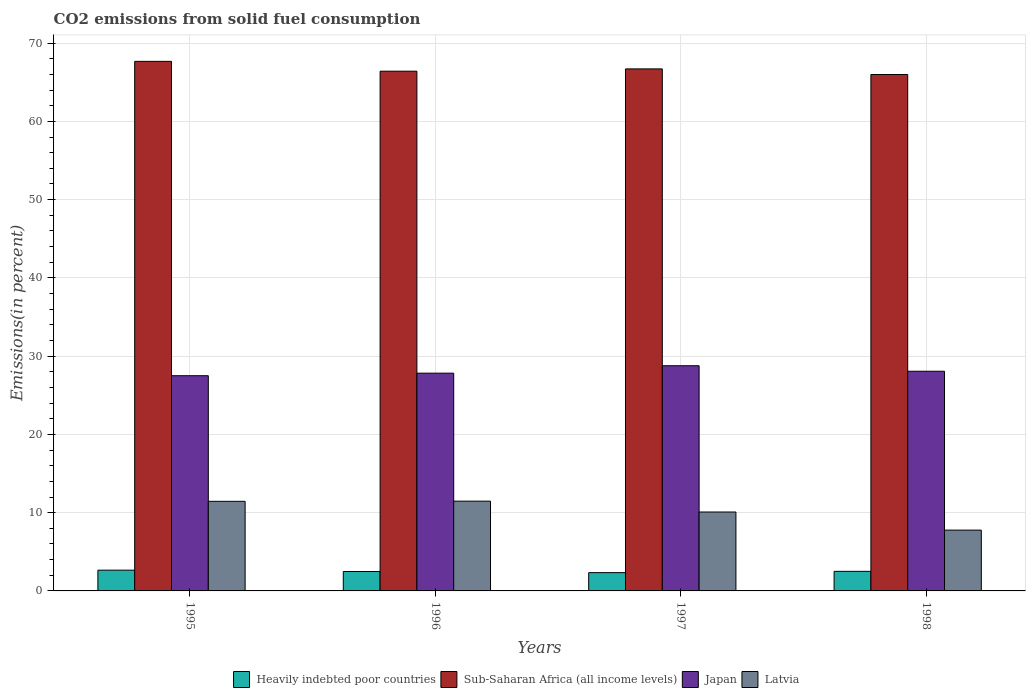How many groups of bars are there?
Provide a succinct answer. 4. Are the number of bars per tick equal to the number of legend labels?
Offer a terse response. Yes. Are the number of bars on each tick of the X-axis equal?
Give a very brief answer. Yes. In how many cases, is the number of bars for a given year not equal to the number of legend labels?
Your response must be concise. 0. What is the total CO2 emitted in Latvia in 1996?
Provide a short and direct response. 11.47. Across all years, what is the maximum total CO2 emitted in Latvia?
Provide a short and direct response. 11.47. Across all years, what is the minimum total CO2 emitted in Latvia?
Keep it short and to the point. 7.77. In which year was the total CO2 emitted in Heavily indebted poor countries minimum?
Give a very brief answer. 1997. What is the total total CO2 emitted in Sub-Saharan Africa (all income levels) in the graph?
Offer a very short reply. 266.77. What is the difference between the total CO2 emitted in Japan in 1997 and that in 1998?
Offer a terse response. 0.7. What is the difference between the total CO2 emitted in Japan in 1996 and the total CO2 emitted in Sub-Saharan Africa (all income levels) in 1995?
Offer a very short reply. -39.84. What is the average total CO2 emitted in Heavily indebted poor countries per year?
Give a very brief answer. 2.49. In the year 1997, what is the difference between the total CO2 emitted in Japan and total CO2 emitted in Heavily indebted poor countries?
Keep it short and to the point. 26.44. In how many years, is the total CO2 emitted in Sub-Saharan Africa (all income levels) greater than 60 %?
Offer a very short reply. 4. What is the ratio of the total CO2 emitted in Japan in 1995 to that in 1997?
Provide a succinct answer. 0.96. What is the difference between the highest and the second highest total CO2 emitted in Japan?
Provide a short and direct response. 0.7. What is the difference between the highest and the lowest total CO2 emitted in Heavily indebted poor countries?
Make the answer very short. 0.32. In how many years, is the total CO2 emitted in Japan greater than the average total CO2 emitted in Japan taken over all years?
Ensure brevity in your answer.  2. What does the 1st bar from the left in 1997 represents?
Ensure brevity in your answer.  Heavily indebted poor countries. What does the 1st bar from the right in 1997 represents?
Provide a short and direct response. Latvia. How many bars are there?
Your response must be concise. 16. How many years are there in the graph?
Make the answer very short. 4. What is the difference between two consecutive major ticks on the Y-axis?
Your response must be concise. 10. Are the values on the major ticks of Y-axis written in scientific E-notation?
Give a very brief answer. No. Does the graph contain any zero values?
Your answer should be very brief. No. Where does the legend appear in the graph?
Ensure brevity in your answer.  Bottom center. What is the title of the graph?
Offer a terse response. CO2 emissions from solid fuel consumption. What is the label or title of the X-axis?
Ensure brevity in your answer.  Years. What is the label or title of the Y-axis?
Provide a succinct answer. Emissions(in percent). What is the Emissions(in percent) in Heavily indebted poor countries in 1995?
Offer a terse response. 2.65. What is the Emissions(in percent) in Sub-Saharan Africa (all income levels) in 1995?
Keep it short and to the point. 67.67. What is the Emissions(in percent) in Japan in 1995?
Your answer should be very brief. 27.5. What is the Emissions(in percent) of Latvia in 1995?
Make the answer very short. 11.45. What is the Emissions(in percent) in Heavily indebted poor countries in 1996?
Make the answer very short. 2.48. What is the Emissions(in percent) in Sub-Saharan Africa (all income levels) in 1996?
Give a very brief answer. 66.41. What is the Emissions(in percent) of Japan in 1996?
Make the answer very short. 27.83. What is the Emissions(in percent) in Latvia in 1996?
Offer a terse response. 11.47. What is the Emissions(in percent) in Heavily indebted poor countries in 1997?
Provide a short and direct response. 2.34. What is the Emissions(in percent) in Sub-Saharan Africa (all income levels) in 1997?
Your answer should be compact. 66.7. What is the Emissions(in percent) in Japan in 1997?
Keep it short and to the point. 28.77. What is the Emissions(in percent) of Latvia in 1997?
Your answer should be very brief. 10.08. What is the Emissions(in percent) in Heavily indebted poor countries in 1998?
Your answer should be compact. 2.5. What is the Emissions(in percent) of Sub-Saharan Africa (all income levels) in 1998?
Give a very brief answer. 65.99. What is the Emissions(in percent) in Japan in 1998?
Offer a very short reply. 28.07. What is the Emissions(in percent) in Latvia in 1998?
Your answer should be very brief. 7.77. Across all years, what is the maximum Emissions(in percent) of Heavily indebted poor countries?
Ensure brevity in your answer.  2.65. Across all years, what is the maximum Emissions(in percent) of Sub-Saharan Africa (all income levels)?
Ensure brevity in your answer.  67.67. Across all years, what is the maximum Emissions(in percent) of Japan?
Your answer should be very brief. 28.77. Across all years, what is the maximum Emissions(in percent) in Latvia?
Offer a terse response. 11.47. Across all years, what is the minimum Emissions(in percent) in Heavily indebted poor countries?
Your answer should be compact. 2.34. Across all years, what is the minimum Emissions(in percent) in Sub-Saharan Africa (all income levels)?
Ensure brevity in your answer.  65.99. Across all years, what is the minimum Emissions(in percent) of Japan?
Provide a short and direct response. 27.5. Across all years, what is the minimum Emissions(in percent) of Latvia?
Provide a succinct answer. 7.77. What is the total Emissions(in percent) of Heavily indebted poor countries in the graph?
Offer a terse response. 9.97. What is the total Emissions(in percent) of Sub-Saharan Africa (all income levels) in the graph?
Ensure brevity in your answer.  266.77. What is the total Emissions(in percent) in Japan in the graph?
Your answer should be compact. 112.17. What is the total Emissions(in percent) in Latvia in the graph?
Your answer should be very brief. 40.77. What is the difference between the Emissions(in percent) in Heavily indebted poor countries in 1995 and that in 1996?
Ensure brevity in your answer.  0.17. What is the difference between the Emissions(in percent) of Sub-Saharan Africa (all income levels) in 1995 and that in 1996?
Make the answer very short. 1.26. What is the difference between the Emissions(in percent) of Japan in 1995 and that in 1996?
Your answer should be compact. -0.33. What is the difference between the Emissions(in percent) of Latvia in 1995 and that in 1996?
Your response must be concise. -0.02. What is the difference between the Emissions(in percent) in Heavily indebted poor countries in 1995 and that in 1997?
Keep it short and to the point. 0.32. What is the difference between the Emissions(in percent) of Sub-Saharan Africa (all income levels) in 1995 and that in 1997?
Offer a very short reply. 0.96. What is the difference between the Emissions(in percent) in Japan in 1995 and that in 1997?
Ensure brevity in your answer.  -1.27. What is the difference between the Emissions(in percent) in Latvia in 1995 and that in 1997?
Keep it short and to the point. 1.37. What is the difference between the Emissions(in percent) in Heavily indebted poor countries in 1995 and that in 1998?
Give a very brief answer. 0.15. What is the difference between the Emissions(in percent) in Sub-Saharan Africa (all income levels) in 1995 and that in 1998?
Make the answer very short. 1.68. What is the difference between the Emissions(in percent) in Japan in 1995 and that in 1998?
Offer a very short reply. -0.57. What is the difference between the Emissions(in percent) in Latvia in 1995 and that in 1998?
Your answer should be very brief. 3.68. What is the difference between the Emissions(in percent) of Heavily indebted poor countries in 1996 and that in 1997?
Provide a succinct answer. 0.15. What is the difference between the Emissions(in percent) of Sub-Saharan Africa (all income levels) in 1996 and that in 1997?
Keep it short and to the point. -0.29. What is the difference between the Emissions(in percent) in Japan in 1996 and that in 1997?
Give a very brief answer. -0.95. What is the difference between the Emissions(in percent) of Latvia in 1996 and that in 1997?
Make the answer very short. 1.39. What is the difference between the Emissions(in percent) in Heavily indebted poor countries in 1996 and that in 1998?
Keep it short and to the point. -0.02. What is the difference between the Emissions(in percent) of Sub-Saharan Africa (all income levels) in 1996 and that in 1998?
Keep it short and to the point. 0.42. What is the difference between the Emissions(in percent) of Japan in 1996 and that in 1998?
Your response must be concise. -0.25. What is the difference between the Emissions(in percent) in Latvia in 1996 and that in 1998?
Your answer should be very brief. 3.7. What is the difference between the Emissions(in percent) of Heavily indebted poor countries in 1997 and that in 1998?
Offer a very short reply. -0.17. What is the difference between the Emissions(in percent) in Sub-Saharan Africa (all income levels) in 1997 and that in 1998?
Offer a very short reply. 0.72. What is the difference between the Emissions(in percent) of Japan in 1997 and that in 1998?
Your response must be concise. 0.7. What is the difference between the Emissions(in percent) in Latvia in 1997 and that in 1998?
Provide a short and direct response. 2.31. What is the difference between the Emissions(in percent) of Heavily indebted poor countries in 1995 and the Emissions(in percent) of Sub-Saharan Africa (all income levels) in 1996?
Make the answer very short. -63.76. What is the difference between the Emissions(in percent) of Heavily indebted poor countries in 1995 and the Emissions(in percent) of Japan in 1996?
Offer a terse response. -25.17. What is the difference between the Emissions(in percent) in Heavily indebted poor countries in 1995 and the Emissions(in percent) in Latvia in 1996?
Make the answer very short. -8.82. What is the difference between the Emissions(in percent) in Sub-Saharan Africa (all income levels) in 1995 and the Emissions(in percent) in Japan in 1996?
Make the answer very short. 39.84. What is the difference between the Emissions(in percent) in Sub-Saharan Africa (all income levels) in 1995 and the Emissions(in percent) in Latvia in 1996?
Your answer should be very brief. 56.2. What is the difference between the Emissions(in percent) of Japan in 1995 and the Emissions(in percent) of Latvia in 1996?
Give a very brief answer. 16.03. What is the difference between the Emissions(in percent) of Heavily indebted poor countries in 1995 and the Emissions(in percent) of Sub-Saharan Africa (all income levels) in 1997?
Ensure brevity in your answer.  -64.05. What is the difference between the Emissions(in percent) of Heavily indebted poor countries in 1995 and the Emissions(in percent) of Japan in 1997?
Keep it short and to the point. -26.12. What is the difference between the Emissions(in percent) of Heavily indebted poor countries in 1995 and the Emissions(in percent) of Latvia in 1997?
Your answer should be compact. -7.43. What is the difference between the Emissions(in percent) of Sub-Saharan Africa (all income levels) in 1995 and the Emissions(in percent) of Japan in 1997?
Provide a succinct answer. 38.9. What is the difference between the Emissions(in percent) of Sub-Saharan Africa (all income levels) in 1995 and the Emissions(in percent) of Latvia in 1997?
Offer a terse response. 57.59. What is the difference between the Emissions(in percent) of Japan in 1995 and the Emissions(in percent) of Latvia in 1997?
Your response must be concise. 17.42. What is the difference between the Emissions(in percent) of Heavily indebted poor countries in 1995 and the Emissions(in percent) of Sub-Saharan Africa (all income levels) in 1998?
Provide a succinct answer. -63.34. What is the difference between the Emissions(in percent) of Heavily indebted poor countries in 1995 and the Emissions(in percent) of Japan in 1998?
Your response must be concise. -25.42. What is the difference between the Emissions(in percent) in Heavily indebted poor countries in 1995 and the Emissions(in percent) in Latvia in 1998?
Provide a succinct answer. -5.12. What is the difference between the Emissions(in percent) in Sub-Saharan Africa (all income levels) in 1995 and the Emissions(in percent) in Japan in 1998?
Your response must be concise. 39.6. What is the difference between the Emissions(in percent) of Sub-Saharan Africa (all income levels) in 1995 and the Emissions(in percent) of Latvia in 1998?
Your response must be concise. 59.9. What is the difference between the Emissions(in percent) in Japan in 1995 and the Emissions(in percent) in Latvia in 1998?
Keep it short and to the point. 19.73. What is the difference between the Emissions(in percent) of Heavily indebted poor countries in 1996 and the Emissions(in percent) of Sub-Saharan Africa (all income levels) in 1997?
Give a very brief answer. -64.22. What is the difference between the Emissions(in percent) of Heavily indebted poor countries in 1996 and the Emissions(in percent) of Japan in 1997?
Make the answer very short. -26.29. What is the difference between the Emissions(in percent) in Heavily indebted poor countries in 1996 and the Emissions(in percent) in Latvia in 1997?
Your answer should be very brief. -7.6. What is the difference between the Emissions(in percent) of Sub-Saharan Africa (all income levels) in 1996 and the Emissions(in percent) of Japan in 1997?
Your answer should be very brief. 37.64. What is the difference between the Emissions(in percent) in Sub-Saharan Africa (all income levels) in 1996 and the Emissions(in percent) in Latvia in 1997?
Your answer should be compact. 56.33. What is the difference between the Emissions(in percent) in Japan in 1996 and the Emissions(in percent) in Latvia in 1997?
Ensure brevity in your answer.  17.74. What is the difference between the Emissions(in percent) in Heavily indebted poor countries in 1996 and the Emissions(in percent) in Sub-Saharan Africa (all income levels) in 1998?
Offer a very short reply. -63.51. What is the difference between the Emissions(in percent) of Heavily indebted poor countries in 1996 and the Emissions(in percent) of Japan in 1998?
Make the answer very short. -25.59. What is the difference between the Emissions(in percent) of Heavily indebted poor countries in 1996 and the Emissions(in percent) of Latvia in 1998?
Your response must be concise. -5.29. What is the difference between the Emissions(in percent) of Sub-Saharan Africa (all income levels) in 1996 and the Emissions(in percent) of Japan in 1998?
Offer a very short reply. 38.34. What is the difference between the Emissions(in percent) in Sub-Saharan Africa (all income levels) in 1996 and the Emissions(in percent) in Latvia in 1998?
Ensure brevity in your answer.  58.64. What is the difference between the Emissions(in percent) in Japan in 1996 and the Emissions(in percent) in Latvia in 1998?
Give a very brief answer. 20.06. What is the difference between the Emissions(in percent) in Heavily indebted poor countries in 1997 and the Emissions(in percent) in Sub-Saharan Africa (all income levels) in 1998?
Provide a short and direct response. -63.65. What is the difference between the Emissions(in percent) of Heavily indebted poor countries in 1997 and the Emissions(in percent) of Japan in 1998?
Keep it short and to the point. -25.74. What is the difference between the Emissions(in percent) of Heavily indebted poor countries in 1997 and the Emissions(in percent) of Latvia in 1998?
Give a very brief answer. -5.43. What is the difference between the Emissions(in percent) of Sub-Saharan Africa (all income levels) in 1997 and the Emissions(in percent) of Japan in 1998?
Your response must be concise. 38.63. What is the difference between the Emissions(in percent) of Sub-Saharan Africa (all income levels) in 1997 and the Emissions(in percent) of Latvia in 1998?
Provide a succinct answer. 58.94. What is the difference between the Emissions(in percent) of Japan in 1997 and the Emissions(in percent) of Latvia in 1998?
Offer a very short reply. 21. What is the average Emissions(in percent) in Heavily indebted poor countries per year?
Provide a succinct answer. 2.49. What is the average Emissions(in percent) of Sub-Saharan Africa (all income levels) per year?
Offer a very short reply. 66.69. What is the average Emissions(in percent) in Japan per year?
Provide a short and direct response. 28.04. What is the average Emissions(in percent) of Latvia per year?
Keep it short and to the point. 10.19. In the year 1995, what is the difference between the Emissions(in percent) of Heavily indebted poor countries and Emissions(in percent) of Sub-Saharan Africa (all income levels)?
Ensure brevity in your answer.  -65.02. In the year 1995, what is the difference between the Emissions(in percent) in Heavily indebted poor countries and Emissions(in percent) in Japan?
Provide a succinct answer. -24.85. In the year 1995, what is the difference between the Emissions(in percent) in Heavily indebted poor countries and Emissions(in percent) in Latvia?
Provide a short and direct response. -8.8. In the year 1995, what is the difference between the Emissions(in percent) in Sub-Saharan Africa (all income levels) and Emissions(in percent) in Japan?
Give a very brief answer. 40.17. In the year 1995, what is the difference between the Emissions(in percent) in Sub-Saharan Africa (all income levels) and Emissions(in percent) in Latvia?
Your response must be concise. 56.22. In the year 1995, what is the difference between the Emissions(in percent) of Japan and Emissions(in percent) of Latvia?
Ensure brevity in your answer.  16.05. In the year 1996, what is the difference between the Emissions(in percent) of Heavily indebted poor countries and Emissions(in percent) of Sub-Saharan Africa (all income levels)?
Give a very brief answer. -63.93. In the year 1996, what is the difference between the Emissions(in percent) of Heavily indebted poor countries and Emissions(in percent) of Japan?
Your answer should be compact. -25.34. In the year 1996, what is the difference between the Emissions(in percent) in Heavily indebted poor countries and Emissions(in percent) in Latvia?
Your answer should be compact. -8.99. In the year 1996, what is the difference between the Emissions(in percent) of Sub-Saharan Africa (all income levels) and Emissions(in percent) of Japan?
Your response must be concise. 38.59. In the year 1996, what is the difference between the Emissions(in percent) of Sub-Saharan Africa (all income levels) and Emissions(in percent) of Latvia?
Make the answer very short. 54.94. In the year 1996, what is the difference between the Emissions(in percent) in Japan and Emissions(in percent) in Latvia?
Your answer should be compact. 16.35. In the year 1997, what is the difference between the Emissions(in percent) in Heavily indebted poor countries and Emissions(in percent) in Sub-Saharan Africa (all income levels)?
Give a very brief answer. -64.37. In the year 1997, what is the difference between the Emissions(in percent) in Heavily indebted poor countries and Emissions(in percent) in Japan?
Your answer should be compact. -26.44. In the year 1997, what is the difference between the Emissions(in percent) in Heavily indebted poor countries and Emissions(in percent) in Latvia?
Make the answer very short. -7.75. In the year 1997, what is the difference between the Emissions(in percent) of Sub-Saharan Africa (all income levels) and Emissions(in percent) of Japan?
Offer a terse response. 37.93. In the year 1997, what is the difference between the Emissions(in percent) of Sub-Saharan Africa (all income levels) and Emissions(in percent) of Latvia?
Your answer should be very brief. 56.62. In the year 1997, what is the difference between the Emissions(in percent) of Japan and Emissions(in percent) of Latvia?
Provide a short and direct response. 18.69. In the year 1998, what is the difference between the Emissions(in percent) in Heavily indebted poor countries and Emissions(in percent) in Sub-Saharan Africa (all income levels)?
Provide a succinct answer. -63.49. In the year 1998, what is the difference between the Emissions(in percent) in Heavily indebted poor countries and Emissions(in percent) in Japan?
Your response must be concise. -25.57. In the year 1998, what is the difference between the Emissions(in percent) in Heavily indebted poor countries and Emissions(in percent) in Latvia?
Keep it short and to the point. -5.27. In the year 1998, what is the difference between the Emissions(in percent) in Sub-Saharan Africa (all income levels) and Emissions(in percent) in Japan?
Offer a very short reply. 37.92. In the year 1998, what is the difference between the Emissions(in percent) in Sub-Saharan Africa (all income levels) and Emissions(in percent) in Latvia?
Your answer should be very brief. 58.22. In the year 1998, what is the difference between the Emissions(in percent) of Japan and Emissions(in percent) of Latvia?
Give a very brief answer. 20.3. What is the ratio of the Emissions(in percent) in Heavily indebted poor countries in 1995 to that in 1996?
Your answer should be very brief. 1.07. What is the ratio of the Emissions(in percent) in Sub-Saharan Africa (all income levels) in 1995 to that in 1996?
Provide a short and direct response. 1.02. What is the ratio of the Emissions(in percent) in Japan in 1995 to that in 1996?
Your answer should be compact. 0.99. What is the ratio of the Emissions(in percent) in Latvia in 1995 to that in 1996?
Provide a succinct answer. 1. What is the ratio of the Emissions(in percent) in Heavily indebted poor countries in 1995 to that in 1997?
Your answer should be compact. 1.14. What is the ratio of the Emissions(in percent) of Sub-Saharan Africa (all income levels) in 1995 to that in 1997?
Your answer should be very brief. 1.01. What is the ratio of the Emissions(in percent) of Japan in 1995 to that in 1997?
Make the answer very short. 0.96. What is the ratio of the Emissions(in percent) in Latvia in 1995 to that in 1997?
Ensure brevity in your answer.  1.14. What is the ratio of the Emissions(in percent) in Heavily indebted poor countries in 1995 to that in 1998?
Offer a terse response. 1.06. What is the ratio of the Emissions(in percent) in Sub-Saharan Africa (all income levels) in 1995 to that in 1998?
Offer a very short reply. 1.03. What is the ratio of the Emissions(in percent) in Japan in 1995 to that in 1998?
Ensure brevity in your answer.  0.98. What is the ratio of the Emissions(in percent) in Latvia in 1995 to that in 1998?
Provide a succinct answer. 1.47. What is the ratio of the Emissions(in percent) of Heavily indebted poor countries in 1996 to that in 1997?
Ensure brevity in your answer.  1.06. What is the ratio of the Emissions(in percent) of Sub-Saharan Africa (all income levels) in 1996 to that in 1997?
Provide a succinct answer. 1. What is the ratio of the Emissions(in percent) of Japan in 1996 to that in 1997?
Give a very brief answer. 0.97. What is the ratio of the Emissions(in percent) in Latvia in 1996 to that in 1997?
Give a very brief answer. 1.14. What is the ratio of the Emissions(in percent) of Heavily indebted poor countries in 1996 to that in 1998?
Keep it short and to the point. 0.99. What is the ratio of the Emissions(in percent) in Sub-Saharan Africa (all income levels) in 1996 to that in 1998?
Give a very brief answer. 1.01. What is the ratio of the Emissions(in percent) in Latvia in 1996 to that in 1998?
Your answer should be compact. 1.48. What is the ratio of the Emissions(in percent) in Heavily indebted poor countries in 1997 to that in 1998?
Make the answer very short. 0.93. What is the ratio of the Emissions(in percent) in Sub-Saharan Africa (all income levels) in 1997 to that in 1998?
Provide a succinct answer. 1.01. What is the ratio of the Emissions(in percent) in Latvia in 1997 to that in 1998?
Give a very brief answer. 1.3. What is the difference between the highest and the second highest Emissions(in percent) in Heavily indebted poor countries?
Provide a succinct answer. 0.15. What is the difference between the highest and the second highest Emissions(in percent) of Sub-Saharan Africa (all income levels)?
Offer a very short reply. 0.96. What is the difference between the highest and the second highest Emissions(in percent) of Japan?
Ensure brevity in your answer.  0.7. What is the difference between the highest and the second highest Emissions(in percent) in Latvia?
Provide a succinct answer. 0.02. What is the difference between the highest and the lowest Emissions(in percent) of Heavily indebted poor countries?
Keep it short and to the point. 0.32. What is the difference between the highest and the lowest Emissions(in percent) of Sub-Saharan Africa (all income levels)?
Your answer should be compact. 1.68. What is the difference between the highest and the lowest Emissions(in percent) in Japan?
Your answer should be very brief. 1.27. What is the difference between the highest and the lowest Emissions(in percent) of Latvia?
Give a very brief answer. 3.7. 